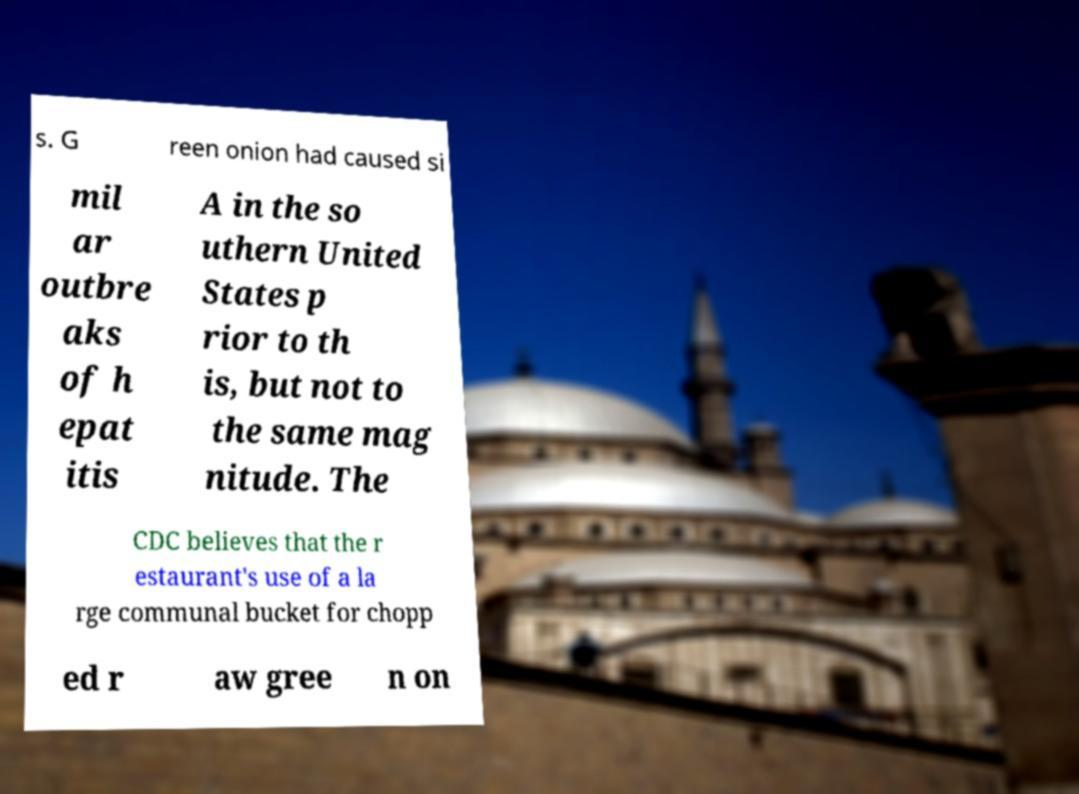Can you accurately transcribe the text from the provided image for me? s. G reen onion had caused si mil ar outbre aks of h epat itis A in the so uthern United States p rior to th is, but not to the same mag nitude. The CDC believes that the r estaurant's use of a la rge communal bucket for chopp ed r aw gree n on 